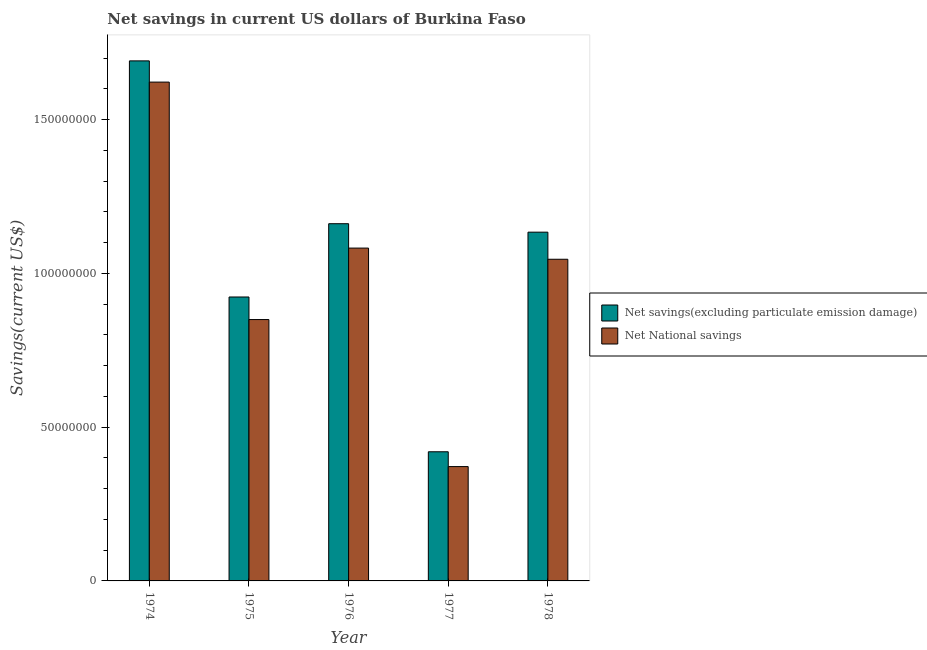Are the number of bars per tick equal to the number of legend labels?
Your answer should be compact. Yes. How many bars are there on the 5th tick from the left?
Offer a terse response. 2. What is the label of the 4th group of bars from the left?
Offer a very short reply. 1977. In how many cases, is the number of bars for a given year not equal to the number of legend labels?
Provide a succinct answer. 0. What is the net savings(excluding particulate emission damage) in 1976?
Offer a terse response. 1.16e+08. Across all years, what is the maximum net savings(excluding particulate emission damage)?
Provide a short and direct response. 1.69e+08. Across all years, what is the minimum net savings(excluding particulate emission damage)?
Your response must be concise. 4.20e+07. In which year was the net savings(excluding particulate emission damage) maximum?
Offer a very short reply. 1974. In which year was the net savings(excluding particulate emission damage) minimum?
Ensure brevity in your answer.  1977. What is the total net savings(excluding particulate emission damage) in the graph?
Your answer should be very brief. 5.33e+08. What is the difference between the net savings(excluding particulate emission damage) in 1974 and that in 1975?
Make the answer very short. 7.68e+07. What is the difference between the net national savings in 1978 and the net savings(excluding particulate emission damage) in 1976?
Offer a very short reply. -3.63e+06. What is the average net savings(excluding particulate emission damage) per year?
Offer a terse response. 1.07e+08. What is the ratio of the net national savings in 1974 to that in 1977?
Your answer should be compact. 4.36. Is the difference between the net national savings in 1974 and 1978 greater than the difference between the net savings(excluding particulate emission damage) in 1974 and 1978?
Provide a succinct answer. No. What is the difference between the highest and the second highest net savings(excluding particulate emission damage)?
Keep it short and to the point. 5.29e+07. What is the difference between the highest and the lowest net national savings?
Offer a terse response. 1.25e+08. In how many years, is the net savings(excluding particulate emission damage) greater than the average net savings(excluding particulate emission damage) taken over all years?
Ensure brevity in your answer.  3. What does the 1st bar from the left in 1978 represents?
Make the answer very short. Net savings(excluding particulate emission damage). What does the 2nd bar from the right in 1974 represents?
Offer a terse response. Net savings(excluding particulate emission damage). Are all the bars in the graph horizontal?
Provide a short and direct response. No. How many years are there in the graph?
Your answer should be compact. 5. What is the difference between two consecutive major ticks on the Y-axis?
Ensure brevity in your answer.  5.00e+07. How are the legend labels stacked?
Give a very brief answer. Vertical. What is the title of the graph?
Your answer should be compact. Net savings in current US dollars of Burkina Faso. What is the label or title of the Y-axis?
Keep it short and to the point. Savings(current US$). What is the Savings(current US$) of Net savings(excluding particulate emission damage) in 1974?
Provide a succinct answer. 1.69e+08. What is the Savings(current US$) of Net National savings in 1974?
Your answer should be compact. 1.62e+08. What is the Savings(current US$) of Net savings(excluding particulate emission damage) in 1975?
Keep it short and to the point. 9.23e+07. What is the Savings(current US$) of Net National savings in 1975?
Give a very brief answer. 8.50e+07. What is the Savings(current US$) of Net savings(excluding particulate emission damage) in 1976?
Give a very brief answer. 1.16e+08. What is the Savings(current US$) in Net National savings in 1976?
Your response must be concise. 1.08e+08. What is the Savings(current US$) of Net savings(excluding particulate emission damage) in 1977?
Make the answer very short. 4.20e+07. What is the Savings(current US$) of Net National savings in 1977?
Make the answer very short. 3.72e+07. What is the Savings(current US$) of Net savings(excluding particulate emission damage) in 1978?
Provide a succinct answer. 1.13e+08. What is the Savings(current US$) in Net National savings in 1978?
Provide a short and direct response. 1.05e+08. Across all years, what is the maximum Savings(current US$) in Net savings(excluding particulate emission damage)?
Provide a succinct answer. 1.69e+08. Across all years, what is the maximum Savings(current US$) of Net National savings?
Your answer should be compact. 1.62e+08. Across all years, what is the minimum Savings(current US$) of Net savings(excluding particulate emission damage)?
Make the answer very short. 4.20e+07. Across all years, what is the minimum Savings(current US$) of Net National savings?
Make the answer very short. 3.72e+07. What is the total Savings(current US$) in Net savings(excluding particulate emission damage) in the graph?
Your answer should be compact. 5.33e+08. What is the total Savings(current US$) of Net National savings in the graph?
Your answer should be very brief. 4.97e+08. What is the difference between the Savings(current US$) of Net savings(excluding particulate emission damage) in 1974 and that in 1975?
Offer a very short reply. 7.68e+07. What is the difference between the Savings(current US$) in Net National savings in 1974 and that in 1975?
Make the answer very short. 7.72e+07. What is the difference between the Savings(current US$) of Net savings(excluding particulate emission damage) in 1974 and that in 1976?
Ensure brevity in your answer.  5.29e+07. What is the difference between the Savings(current US$) of Net National savings in 1974 and that in 1976?
Keep it short and to the point. 5.40e+07. What is the difference between the Savings(current US$) of Net savings(excluding particulate emission damage) in 1974 and that in 1977?
Keep it short and to the point. 1.27e+08. What is the difference between the Savings(current US$) of Net National savings in 1974 and that in 1977?
Offer a terse response. 1.25e+08. What is the difference between the Savings(current US$) of Net savings(excluding particulate emission damage) in 1974 and that in 1978?
Your answer should be very brief. 5.57e+07. What is the difference between the Savings(current US$) of Net National savings in 1974 and that in 1978?
Provide a succinct answer. 5.76e+07. What is the difference between the Savings(current US$) in Net savings(excluding particulate emission damage) in 1975 and that in 1976?
Your answer should be very brief. -2.38e+07. What is the difference between the Savings(current US$) of Net National savings in 1975 and that in 1976?
Offer a very short reply. -2.32e+07. What is the difference between the Savings(current US$) of Net savings(excluding particulate emission damage) in 1975 and that in 1977?
Provide a succinct answer. 5.03e+07. What is the difference between the Savings(current US$) of Net National savings in 1975 and that in 1977?
Your response must be concise. 4.78e+07. What is the difference between the Savings(current US$) of Net savings(excluding particulate emission damage) in 1975 and that in 1978?
Give a very brief answer. -2.11e+07. What is the difference between the Savings(current US$) in Net National savings in 1975 and that in 1978?
Provide a succinct answer. -1.96e+07. What is the difference between the Savings(current US$) of Net savings(excluding particulate emission damage) in 1976 and that in 1977?
Your answer should be compact. 7.41e+07. What is the difference between the Savings(current US$) of Net National savings in 1976 and that in 1977?
Offer a very short reply. 7.10e+07. What is the difference between the Savings(current US$) in Net savings(excluding particulate emission damage) in 1976 and that in 1978?
Provide a succinct answer. 2.75e+06. What is the difference between the Savings(current US$) in Net National savings in 1976 and that in 1978?
Your answer should be compact. 3.63e+06. What is the difference between the Savings(current US$) in Net savings(excluding particulate emission damage) in 1977 and that in 1978?
Your answer should be very brief. -7.14e+07. What is the difference between the Savings(current US$) in Net National savings in 1977 and that in 1978?
Provide a succinct answer. -6.74e+07. What is the difference between the Savings(current US$) of Net savings(excluding particulate emission damage) in 1974 and the Savings(current US$) of Net National savings in 1975?
Provide a short and direct response. 8.41e+07. What is the difference between the Savings(current US$) in Net savings(excluding particulate emission damage) in 1974 and the Savings(current US$) in Net National savings in 1976?
Your answer should be compact. 6.09e+07. What is the difference between the Savings(current US$) of Net savings(excluding particulate emission damage) in 1974 and the Savings(current US$) of Net National savings in 1977?
Offer a very short reply. 1.32e+08. What is the difference between the Savings(current US$) in Net savings(excluding particulate emission damage) in 1974 and the Savings(current US$) in Net National savings in 1978?
Provide a short and direct response. 6.45e+07. What is the difference between the Savings(current US$) of Net savings(excluding particulate emission damage) in 1975 and the Savings(current US$) of Net National savings in 1976?
Provide a succinct answer. -1.59e+07. What is the difference between the Savings(current US$) in Net savings(excluding particulate emission damage) in 1975 and the Savings(current US$) in Net National savings in 1977?
Make the answer very short. 5.51e+07. What is the difference between the Savings(current US$) in Net savings(excluding particulate emission damage) in 1975 and the Savings(current US$) in Net National savings in 1978?
Provide a succinct answer. -1.23e+07. What is the difference between the Savings(current US$) in Net savings(excluding particulate emission damage) in 1976 and the Savings(current US$) in Net National savings in 1977?
Provide a short and direct response. 7.90e+07. What is the difference between the Savings(current US$) in Net savings(excluding particulate emission damage) in 1976 and the Savings(current US$) in Net National savings in 1978?
Provide a short and direct response. 1.16e+07. What is the difference between the Savings(current US$) of Net savings(excluding particulate emission damage) in 1977 and the Savings(current US$) of Net National savings in 1978?
Make the answer very short. -6.26e+07. What is the average Savings(current US$) in Net savings(excluding particulate emission damage) per year?
Your answer should be very brief. 1.07e+08. What is the average Savings(current US$) in Net National savings per year?
Give a very brief answer. 9.94e+07. In the year 1974, what is the difference between the Savings(current US$) in Net savings(excluding particulate emission damage) and Savings(current US$) in Net National savings?
Provide a short and direct response. 6.90e+06. In the year 1975, what is the difference between the Savings(current US$) of Net savings(excluding particulate emission damage) and Savings(current US$) of Net National savings?
Your answer should be compact. 7.34e+06. In the year 1976, what is the difference between the Savings(current US$) of Net savings(excluding particulate emission damage) and Savings(current US$) of Net National savings?
Keep it short and to the point. 7.93e+06. In the year 1977, what is the difference between the Savings(current US$) in Net savings(excluding particulate emission damage) and Savings(current US$) in Net National savings?
Your answer should be very brief. 4.82e+06. In the year 1978, what is the difference between the Savings(current US$) of Net savings(excluding particulate emission damage) and Savings(current US$) of Net National savings?
Provide a short and direct response. 8.81e+06. What is the ratio of the Savings(current US$) of Net savings(excluding particulate emission damage) in 1974 to that in 1975?
Your answer should be very brief. 1.83. What is the ratio of the Savings(current US$) in Net National savings in 1974 to that in 1975?
Give a very brief answer. 1.91. What is the ratio of the Savings(current US$) in Net savings(excluding particulate emission damage) in 1974 to that in 1976?
Provide a short and direct response. 1.46. What is the ratio of the Savings(current US$) of Net National savings in 1974 to that in 1976?
Offer a very short reply. 1.5. What is the ratio of the Savings(current US$) in Net savings(excluding particulate emission damage) in 1974 to that in 1977?
Ensure brevity in your answer.  4.03. What is the ratio of the Savings(current US$) in Net National savings in 1974 to that in 1977?
Your response must be concise. 4.36. What is the ratio of the Savings(current US$) of Net savings(excluding particulate emission damage) in 1974 to that in 1978?
Provide a short and direct response. 1.49. What is the ratio of the Savings(current US$) of Net National savings in 1974 to that in 1978?
Ensure brevity in your answer.  1.55. What is the ratio of the Savings(current US$) of Net savings(excluding particulate emission damage) in 1975 to that in 1976?
Keep it short and to the point. 0.79. What is the ratio of the Savings(current US$) in Net National savings in 1975 to that in 1976?
Make the answer very short. 0.79. What is the ratio of the Savings(current US$) in Net savings(excluding particulate emission damage) in 1975 to that in 1977?
Your answer should be very brief. 2.2. What is the ratio of the Savings(current US$) of Net National savings in 1975 to that in 1977?
Provide a succinct answer. 2.29. What is the ratio of the Savings(current US$) of Net savings(excluding particulate emission damage) in 1975 to that in 1978?
Provide a short and direct response. 0.81. What is the ratio of the Savings(current US$) of Net National savings in 1975 to that in 1978?
Provide a short and direct response. 0.81. What is the ratio of the Savings(current US$) in Net savings(excluding particulate emission damage) in 1976 to that in 1977?
Make the answer very short. 2.77. What is the ratio of the Savings(current US$) in Net National savings in 1976 to that in 1977?
Offer a terse response. 2.91. What is the ratio of the Savings(current US$) in Net savings(excluding particulate emission damage) in 1976 to that in 1978?
Ensure brevity in your answer.  1.02. What is the ratio of the Savings(current US$) in Net National savings in 1976 to that in 1978?
Make the answer very short. 1.03. What is the ratio of the Savings(current US$) in Net savings(excluding particulate emission damage) in 1977 to that in 1978?
Keep it short and to the point. 0.37. What is the ratio of the Savings(current US$) in Net National savings in 1977 to that in 1978?
Give a very brief answer. 0.36. What is the difference between the highest and the second highest Savings(current US$) of Net savings(excluding particulate emission damage)?
Offer a terse response. 5.29e+07. What is the difference between the highest and the second highest Savings(current US$) in Net National savings?
Provide a short and direct response. 5.40e+07. What is the difference between the highest and the lowest Savings(current US$) in Net savings(excluding particulate emission damage)?
Make the answer very short. 1.27e+08. What is the difference between the highest and the lowest Savings(current US$) in Net National savings?
Your response must be concise. 1.25e+08. 